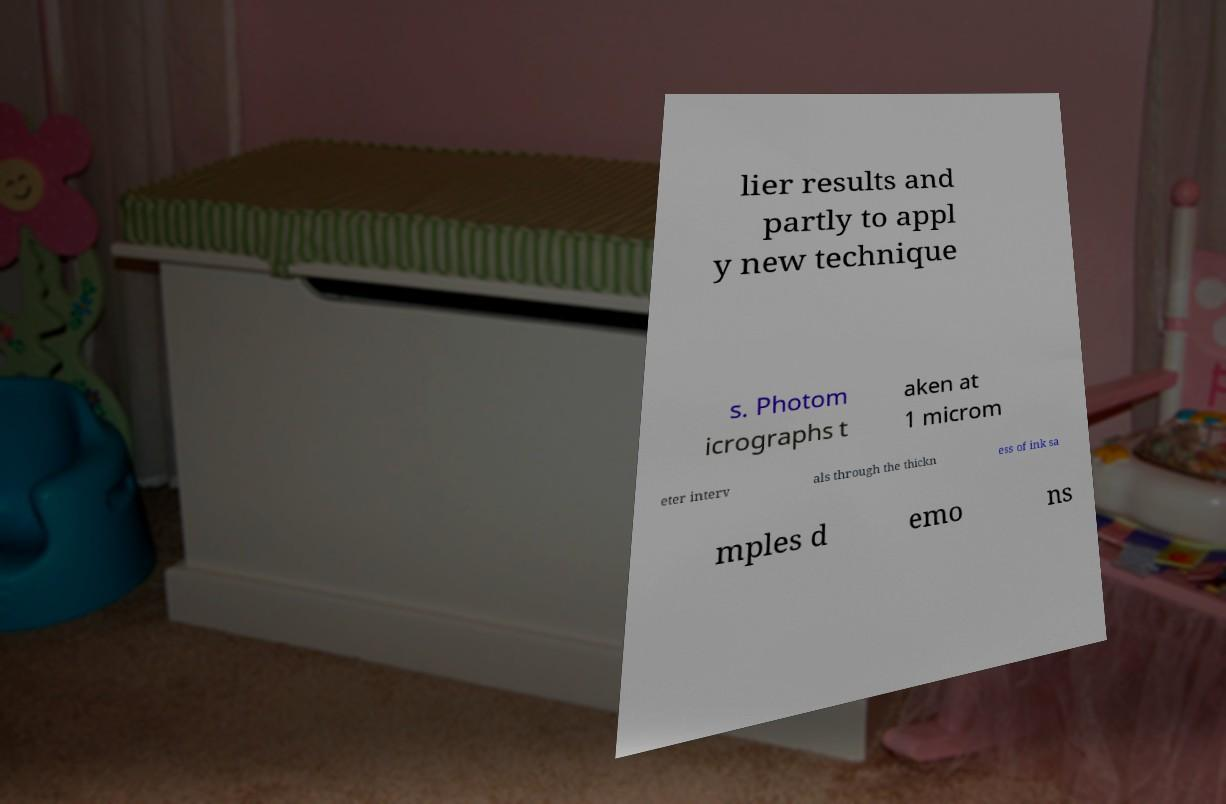There's text embedded in this image that I need extracted. Can you transcribe it verbatim? lier results and partly to appl y new technique s. Photom icrographs t aken at 1 microm eter interv als through the thickn ess of ink sa mples d emo ns 